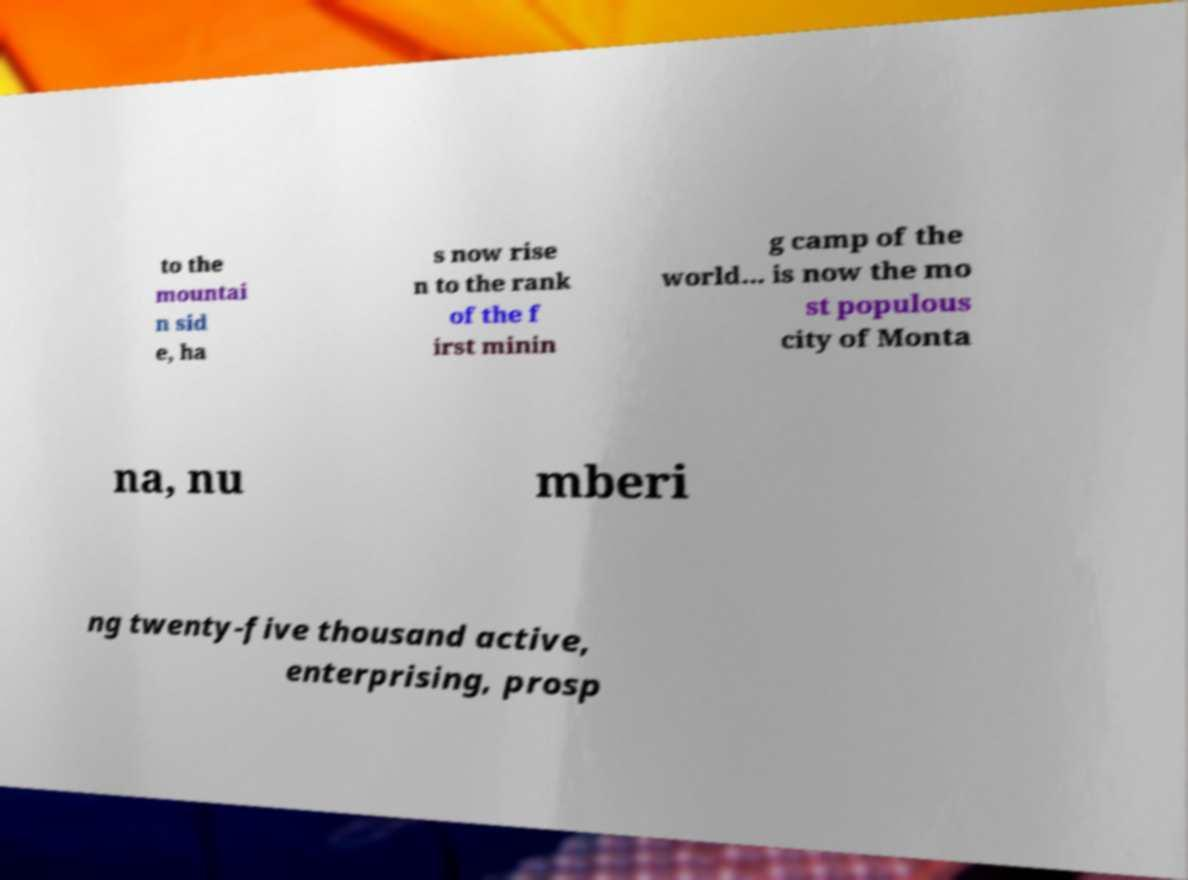What messages or text are displayed in this image? I need them in a readable, typed format. to the mountai n sid e, ha s now rise n to the rank of the f irst minin g camp of the world... is now the mo st populous city of Monta na, nu mberi ng twenty-five thousand active, enterprising, prosp 